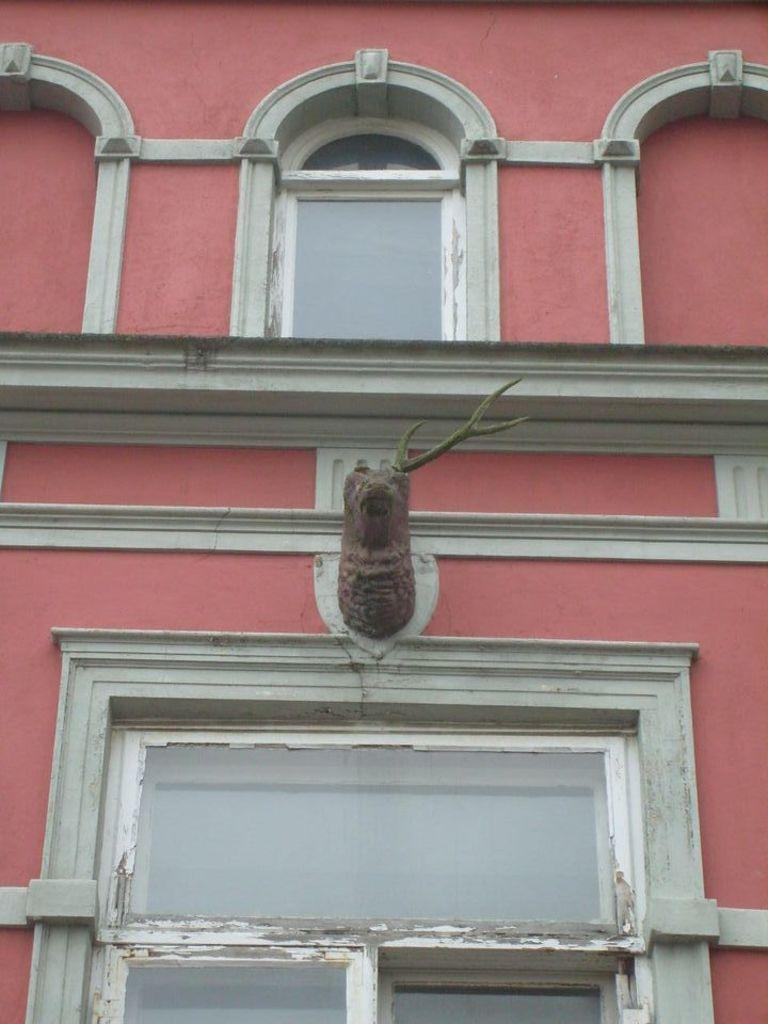What is the main subject in the image? There is a statue in the image. Where is the statue located in relation to the building? The statue is near a building. What can be seen on the building? The building has windows. What is the color of the building? The building is red in color. How many wires are connected to the statue in the image? There are no wires connected to the statue in the image. What type of list is being held by the statue in the image? There is no list present in the image, and the statue is not holding anything. 